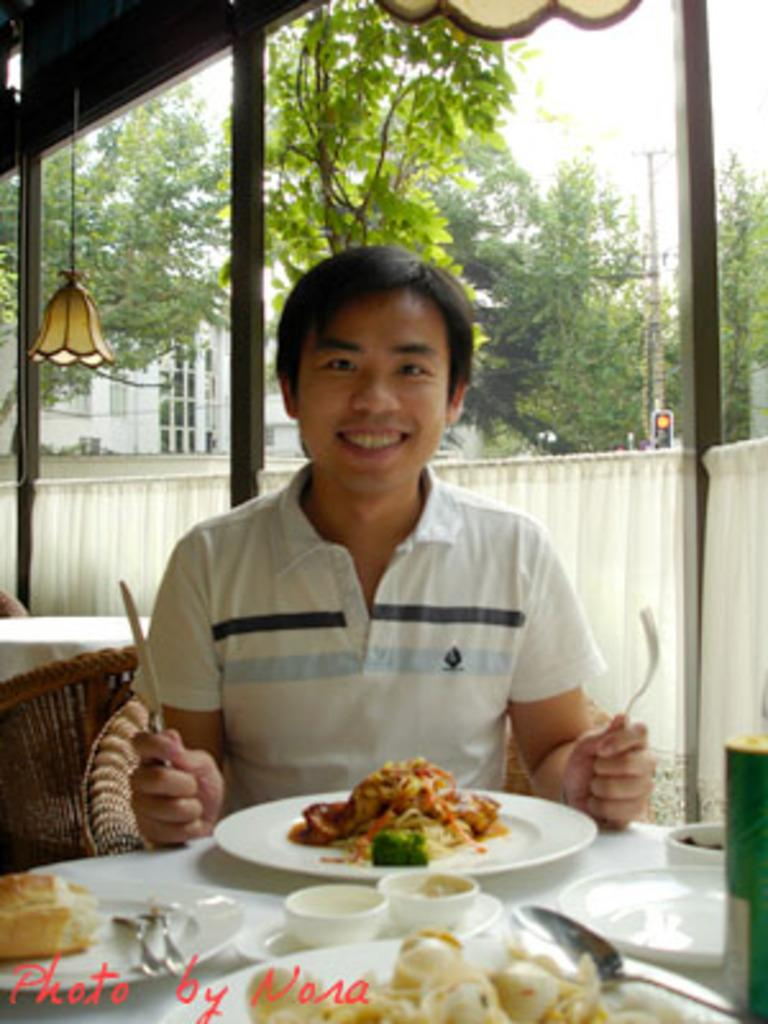Who or what is present in the image? There is a person in the image. What is the person holding in their hands? The person is holding a fork and a knife. What is on the plate that the person might be using the fork and knife with? There is a food item on a plate. What can be seen in the distance behind the person? There are trees visible in the background of the image. What type of grape is being played by the band in the image? There is no grape or band present in the image. How many steps does the person take while holding the fork and knife in the image? The image does not show the person taking any steps while holding the fork and knife. 